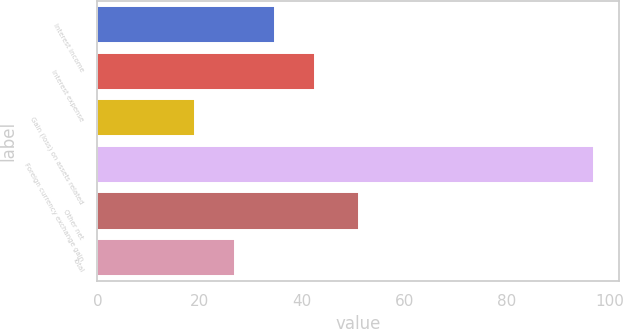Convert chart. <chart><loc_0><loc_0><loc_500><loc_500><bar_chart><fcel>Interest income<fcel>Interest expense<fcel>Gain (loss) on assets related<fcel>Foreign currency exchange gain<fcel>Other net<fcel>Total<nl><fcel>34.6<fcel>42.4<fcel>19<fcel>97<fcel>51<fcel>26.8<nl></chart> 